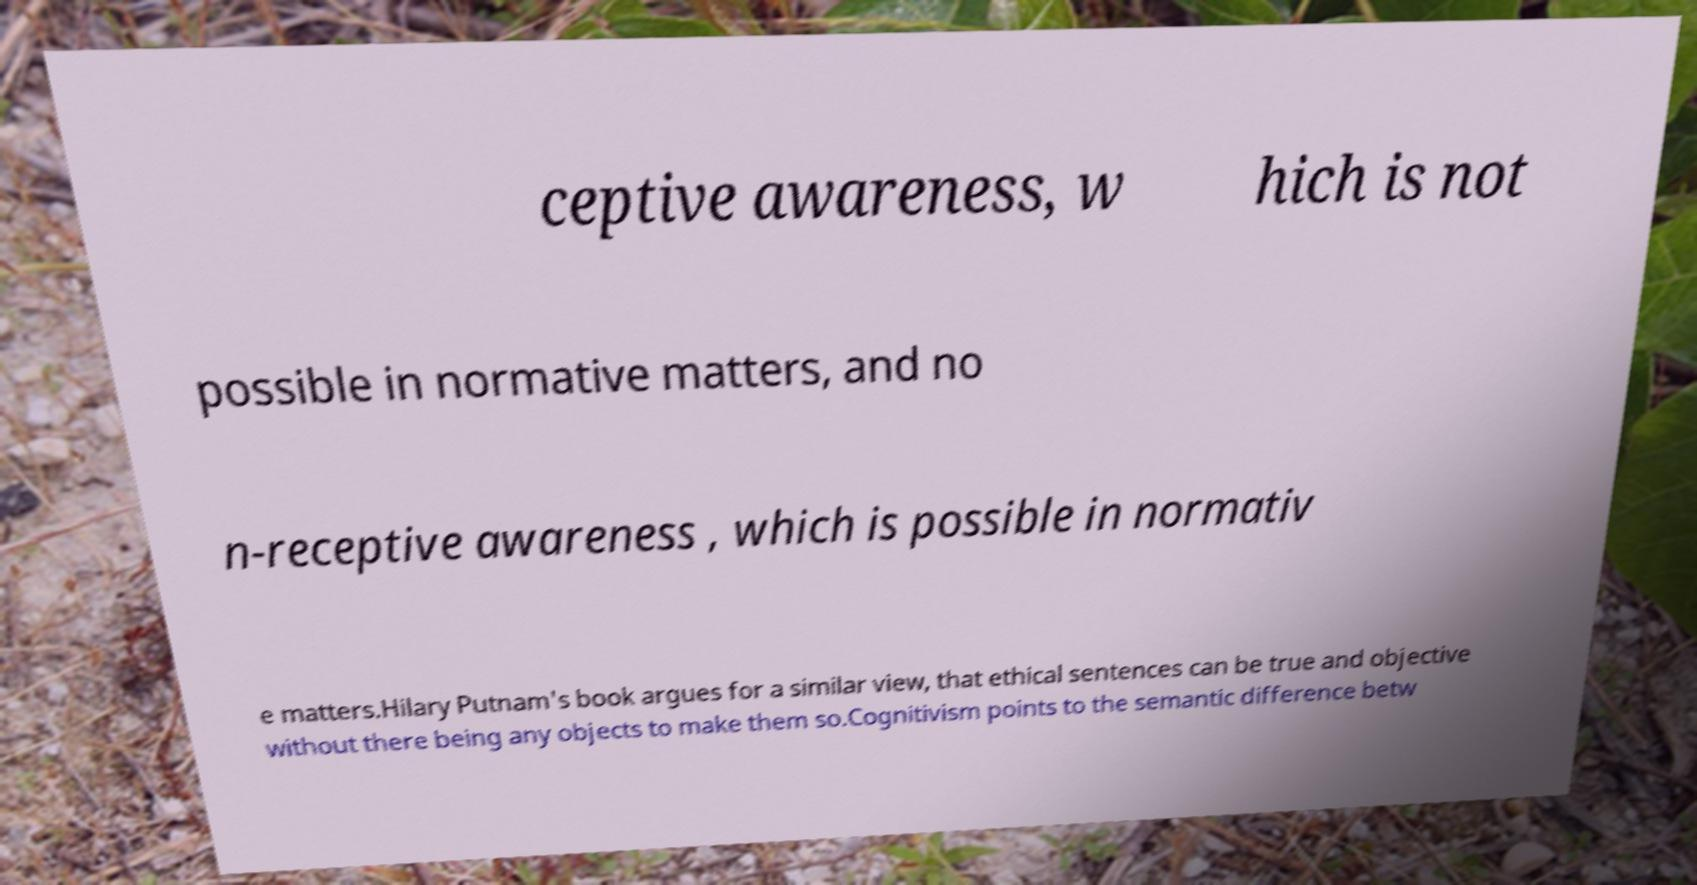There's text embedded in this image that I need extracted. Can you transcribe it verbatim? ceptive awareness, w hich is not possible in normative matters, and no n-receptive awareness , which is possible in normativ e matters.Hilary Putnam's book argues for a similar view, that ethical sentences can be true and objective without there being any objects to make them so.Cognitivism points to the semantic difference betw 